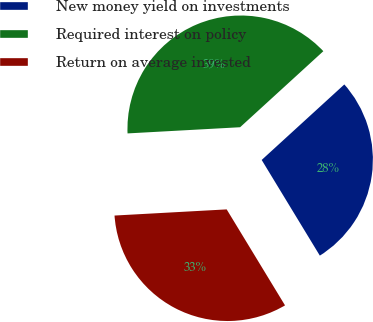Convert chart to OTSL. <chart><loc_0><loc_0><loc_500><loc_500><pie_chart><fcel>New money yield on investments<fcel>Required interest on policy<fcel>Return on average invested<nl><fcel>28.09%<fcel>39.09%<fcel>32.82%<nl></chart> 